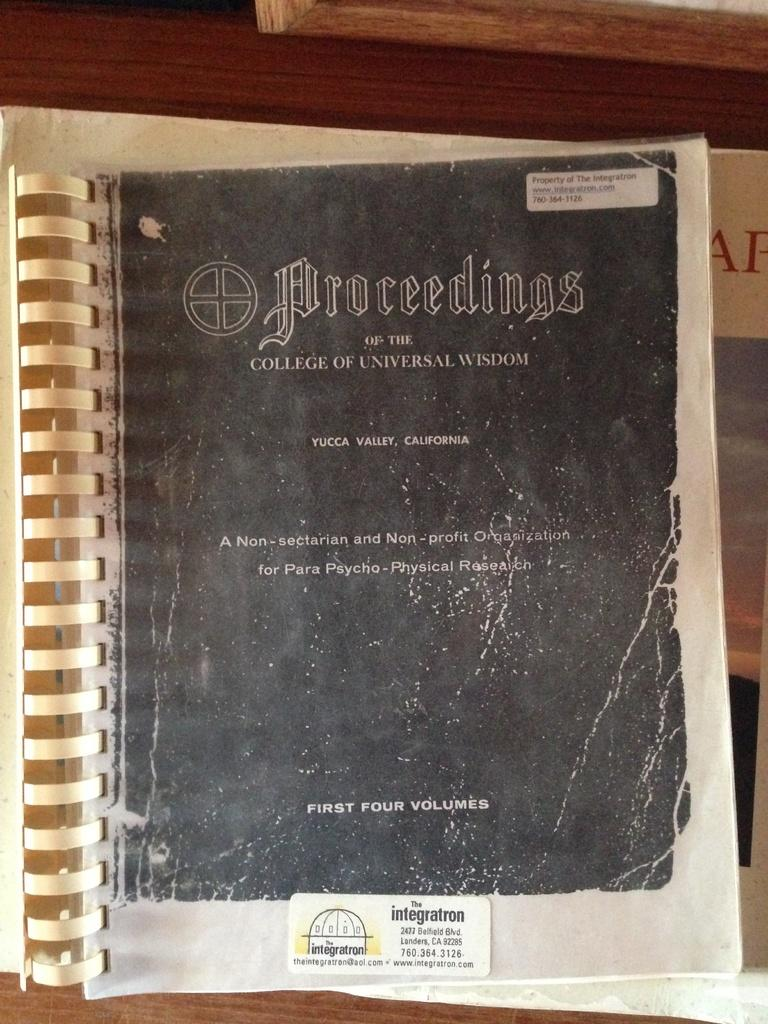What object can be seen in the image? There is a book in the image. Where is the book located? The book is placed on a table. What type of bomb is depicted on the cover of the book in the image? There is no bomb depicted on the cover of the book in the image; it is just a regular book. Can you see the author's smile on the book cover in the image? There is no person or face visible on the book cover in the image, so it is not possible to see a smile. 